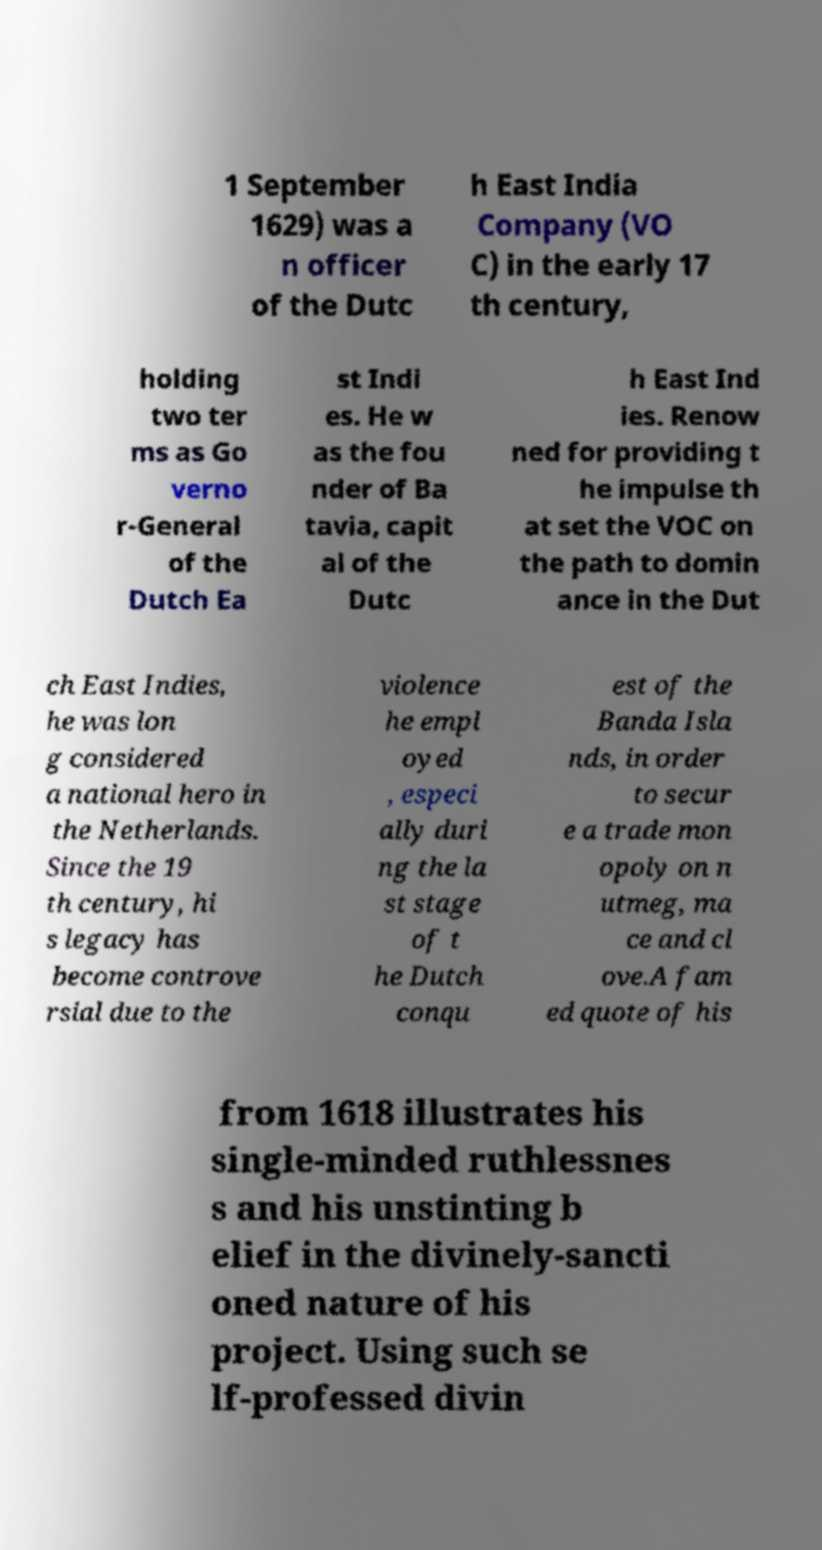Please read and relay the text visible in this image. What does it say? 1 September 1629) was a n officer of the Dutc h East India Company (VO C) in the early 17 th century, holding two ter ms as Go verno r-General of the Dutch Ea st Indi es. He w as the fou nder of Ba tavia, capit al of the Dutc h East Ind ies. Renow ned for providing t he impulse th at set the VOC on the path to domin ance in the Dut ch East Indies, he was lon g considered a national hero in the Netherlands. Since the 19 th century, hi s legacy has become controve rsial due to the violence he empl oyed , especi ally duri ng the la st stage of t he Dutch conqu est of the Banda Isla nds, in order to secur e a trade mon opoly on n utmeg, ma ce and cl ove.A fam ed quote of his from 1618 illustrates his single-minded ruthlessnes s and his unstinting b elief in the divinely-sancti oned nature of his project. Using such se lf-professed divin 